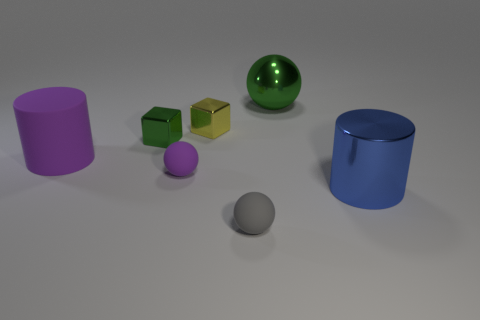Add 1 metal blocks. How many objects exist? 8 Subtract all spheres. How many objects are left? 4 Add 3 tiny green metallic objects. How many tiny green metallic objects exist? 4 Subtract 0 cyan cylinders. How many objects are left? 7 Subtract all large blue metallic balls. Subtract all tiny purple spheres. How many objects are left? 6 Add 5 blue cylinders. How many blue cylinders are left? 6 